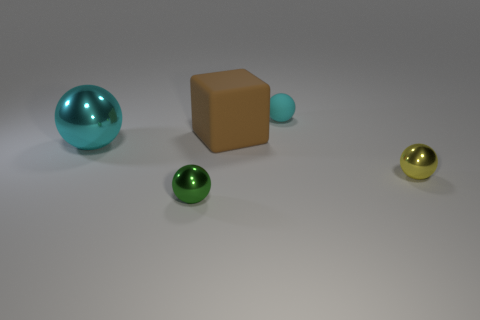Are there any other things of the same color as the block? The block's color appears to be unique among the objects in view. It is a shade of brown, unlike the other spheres which exhibit different colors, such as teal, green, and gold. 